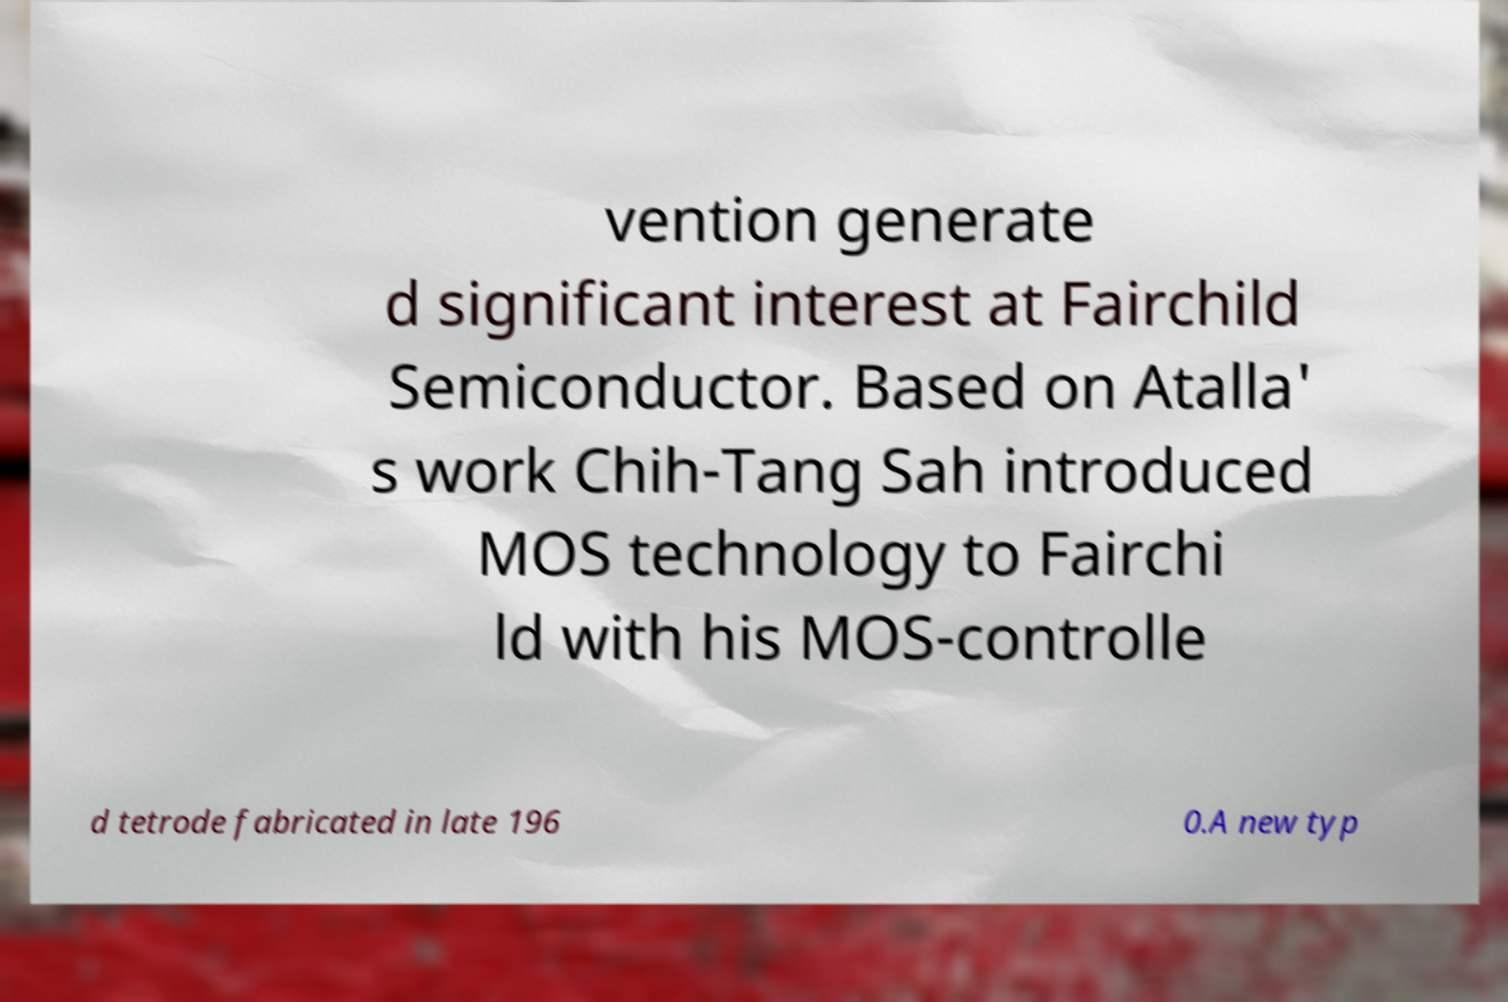Can you read and provide the text displayed in the image?This photo seems to have some interesting text. Can you extract and type it out for me? vention generate d significant interest at Fairchild Semiconductor. Based on Atalla' s work Chih-Tang Sah introduced MOS technology to Fairchi ld with his MOS-controlle d tetrode fabricated in late 196 0.A new typ 